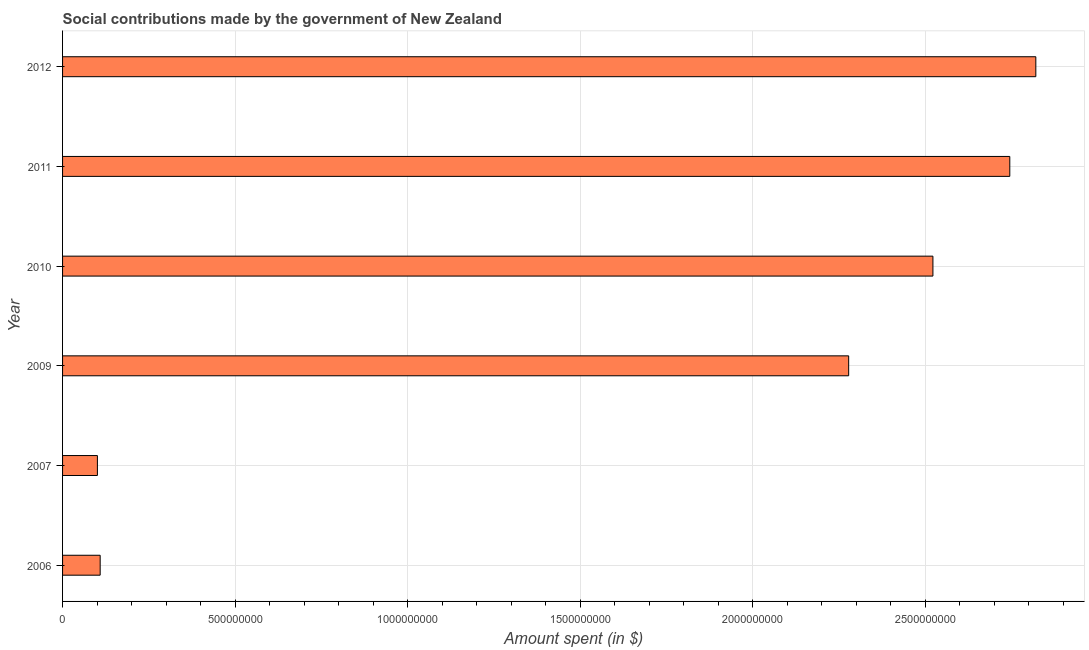Does the graph contain any zero values?
Your response must be concise. No. Does the graph contain grids?
Offer a terse response. Yes. What is the title of the graph?
Keep it short and to the point. Social contributions made by the government of New Zealand. What is the label or title of the X-axis?
Provide a short and direct response. Amount spent (in $). What is the amount spent in making social contributions in 2011?
Offer a terse response. 2.75e+09. Across all years, what is the maximum amount spent in making social contributions?
Make the answer very short. 2.82e+09. Across all years, what is the minimum amount spent in making social contributions?
Make the answer very short. 1.01e+08. In which year was the amount spent in making social contributions maximum?
Keep it short and to the point. 2012. In which year was the amount spent in making social contributions minimum?
Give a very brief answer. 2007. What is the sum of the amount spent in making social contributions?
Keep it short and to the point. 1.06e+1. What is the difference between the amount spent in making social contributions in 2007 and 2010?
Your answer should be compact. -2.42e+09. What is the average amount spent in making social contributions per year?
Ensure brevity in your answer.  1.76e+09. What is the median amount spent in making social contributions?
Give a very brief answer. 2.40e+09. In how many years, is the amount spent in making social contributions greater than 2200000000 $?
Make the answer very short. 4. What is the ratio of the amount spent in making social contributions in 2007 to that in 2012?
Keep it short and to the point. 0.04. Is the amount spent in making social contributions in 2009 less than that in 2012?
Give a very brief answer. Yes. What is the difference between the highest and the second highest amount spent in making social contributions?
Keep it short and to the point. 7.55e+07. Is the sum of the amount spent in making social contributions in 2007 and 2010 greater than the maximum amount spent in making social contributions across all years?
Offer a terse response. No. What is the difference between the highest and the lowest amount spent in making social contributions?
Your response must be concise. 2.72e+09. In how many years, is the amount spent in making social contributions greater than the average amount spent in making social contributions taken over all years?
Ensure brevity in your answer.  4. How many bars are there?
Your answer should be very brief. 6. Are all the bars in the graph horizontal?
Offer a terse response. Yes. Are the values on the major ticks of X-axis written in scientific E-notation?
Your answer should be very brief. No. What is the Amount spent (in $) of 2006?
Offer a very short reply. 1.09e+08. What is the Amount spent (in $) in 2007?
Provide a short and direct response. 1.01e+08. What is the Amount spent (in $) in 2009?
Keep it short and to the point. 2.28e+09. What is the Amount spent (in $) of 2010?
Make the answer very short. 2.52e+09. What is the Amount spent (in $) in 2011?
Offer a very short reply. 2.75e+09. What is the Amount spent (in $) of 2012?
Your answer should be compact. 2.82e+09. What is the difference between the Amount spent (in $) in 2006 and 2007?
Offer a very short reply. 8.00e+06. What is the difference between the Amount spent (in $) in 2006 and 2009?
Your answer should be compact. -2.17e+09. What is the difference between the Amount spent (in $) in 2006 and 2010?
Your response must be concise. -2.41e+09. What is the difference between the Amount spent (in $) in 2006 and 2011?
Offer a terse response. -2.64e+09. What is the difference between the Amount spent (in $) in 2006 and 2012?
Offer a very short reply. -2.71e+09. What is the difference between the Amount spent (in $) in 2007 and 2009?
Provide a short and direct response. -2.18e+09. What is the difference between the Amount spent (in $) in 2007 and 2010?
Provide a short and direct response. -2.42e+09. What is the difference between the Amount spent (in $) in 2007 and 2011?
Give a very brief answer. -2.64e+09. What is the difference between the Amount spent (in $) in 2007 and 2012?
Your response must be concise. -2.72e+09. What is the difference between the Amount spent (in $) in 2009 and 2010?
Your answer should be very brief. -2.44e+08. What is the difference between the Amount spent (in $) in 2009 and 2011?
Your answer should be very brief. -4.67e+08. What is the difference between the Amount spent (in $) in 2009 and 2012?
Your answer should be compact. -5.42e+08. What is the difference between the Amount spent (in $) in 2010 and 2011?
Provide a short and direct response. -2.23e+08. What is the difference between the Amount spent (in $) in 2010 and 2012?
Provide a short and direct response. -2.98e+08. What is the difference between the Amount spent (in $) in 2011 and 2012?
Provide a succinct answer. -7.55e+07. What is the ratio of the Amount spent (in $) in 2006 to that in 2007?
Keep it short and to the point. 1.08. What is the ratio of the Amount spent (in $) in 2006 to that in 2009?
Offer a very short reply. 0.05. What is the ratio of the Amount spent (in $) in 2006 to that in 2010?
Make the answer very short. 0.04. What is the ratio of the Amount spent (in $) in 2006 to that in 2012?
Your response must be concise. 0.04. What is the ratio of the Amount spent (in $) in 2007 to that in 2009?
Your answer should be compact. 0.04. What is the ratio of the Amount spent (in $) in 2007 to that in 2010?
Ensure brevity in your answer.  0.04. What is the ratio of the Amount spent (in $) in 2007 to that in 2011?
Ensure brevity in your answer.  0.04. What is the ratio of the Amount spent (in $) in 2007 to that in 2012?
Your answer should be very brief. 0.04. What is the ratio of the Amount spent (in $) in 2009 to that in 2010?
Offer a terse response. 0.9. What is the ratio of the Amount spent (in $) in 2009 to that in 2011?
Ensure brevity in your answer.  0.83. What is the ratio of the Amount spent (in $) in 2009 to that in 2012?
Offer a very short reply. 0.81. What is the ratio of the Amount spent (in $) in 2010 to that in 2011?
Your answer should be very brief. 0.92. What is the ratio of the Amount spent (in $) in 2010 to that in 2012?
Ensure brevity in your answer.  0.89. What is the ratio of the Amount spent (in $) in 2011 to that in 2012?
Make the answer very short. 0.97. 